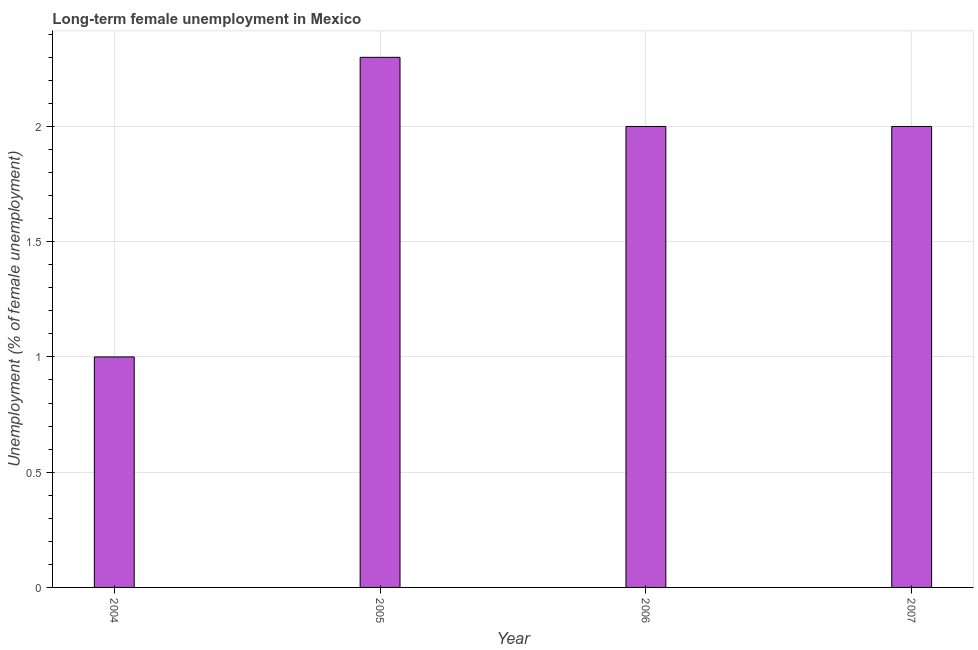Does the graph contain grids?
Provide a succinct answer. Yes. What is the title of the graph?
Offer a very short reply. Long-term female unemployment in Mexico. What is the label or title of the Y-axis?
Provide a short and direct response. Unemployment (% of female unemployment). What is the long-term female unemployment in 2006?
Keep it short and to the point. 2. Across all years, what is the maximum long-term female unemployment?
Your answer should be very brief. 2.3. In which year was the long-term female unemployment maximum?
Make the answer very short. 2005. In which year was the long-term female unemployment minimum?
Keep it short and to the point. 2004. What is the sum of the long-term female unemployment?
Ensure brevity in your answer.  7.3. What is the average long-term female unemployment per year?
Provide a short and direct response. 1.82. What is the median long-term female unemployment?
Your answer should be compact. 2. What is the ratio of the long-term female unemployment in 2006 to that in 2007?
Keep it short and to the point. 1. Is the difference between the long-term female unemployment in 2006 and 2007 greater than the difference between any two years?
Provide a short and direct response. No. What is the difference between the highest and the second highest long-term female unemployment?
Make the answer very short. 0.3. In how many years, is the long-term female unemployment greater than the average long-term female unemployment taken over all years?
Provide a short and direct response. 3. Are all the bars in the graph horizontal?
Ensure brevity in your answer.  No. What is the difference between two consecutive major ticks on the Y-axis?
Give a very brief answer. 0.5. What is the Unemployment (% of female unemployment) in 2004?
Ensure brevity in your answer.  1. What is the Unemployment (% of female unemployment) in 2005?
Offer a terse response. 2.3. What is the Unemployment (% of female unemployment) in 2006?
Ensure brevity in your answer.  2. What is the difference between the Unemployment (% of female unemployment) in 2006 and 2007?
Your answer should be compact. 0. What is the ratio of the Unemployment (% of female unemployment) in 2004 to that in 2005?
Your answer should be compact. 0.43. What is the ratio of the Unemployment (% of female unemployment) in 2004 to that in 2006?
Make the answer very short. 0.5. What is the ratio of the Unemployment (% of female unemployment) in 2005 to that in 2006?
Your answer should be compact. 1.15. What is the ratio of the Unemployment (% of female unemployment) in 2005 to that in 2007?
Offer a terse response. 1.15. What is the ratio of the Unemployment (% of female unemployment) in 2006 to that in 2007?
Keep it short and to the point. 1. 